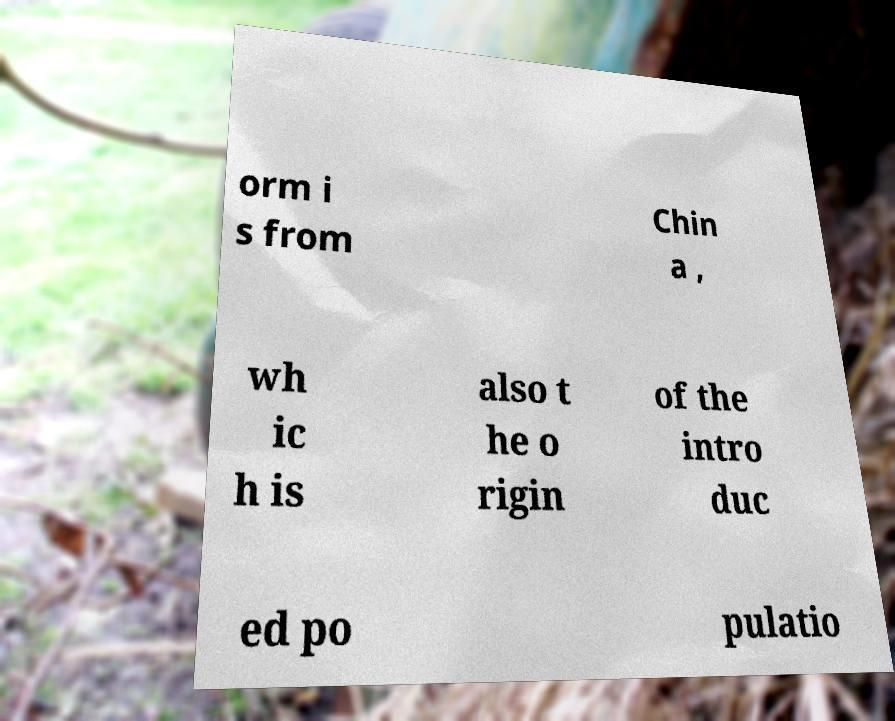Please read and relay the text visible in this image. What does it say? orm i s from Chin a , wh ic h is also t he o rigin of the intro duc ed po pulatio 